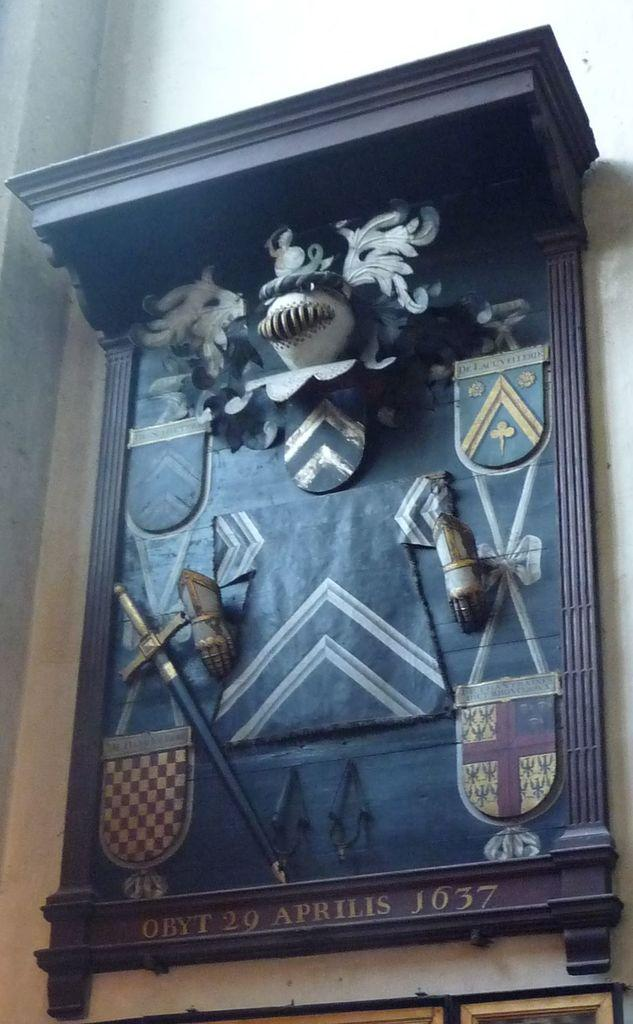What type of material is used for the planks in the image? The planks in the image are made of wood. How are the wooden planks arranged in the image? The wooden planks are attached to a wall. What decorative elements can be seen on the wooden planks? There are sculptures on the wooden planks. What message is written on the wooden planks? The writing on the wooden planks says "OBYT 29 APRILIS J637". What type of wilderness can be seen in the background of the image? There is no wilderness visible in the image; it only shows wooden planks attached to a wall with sculptures and writing. 